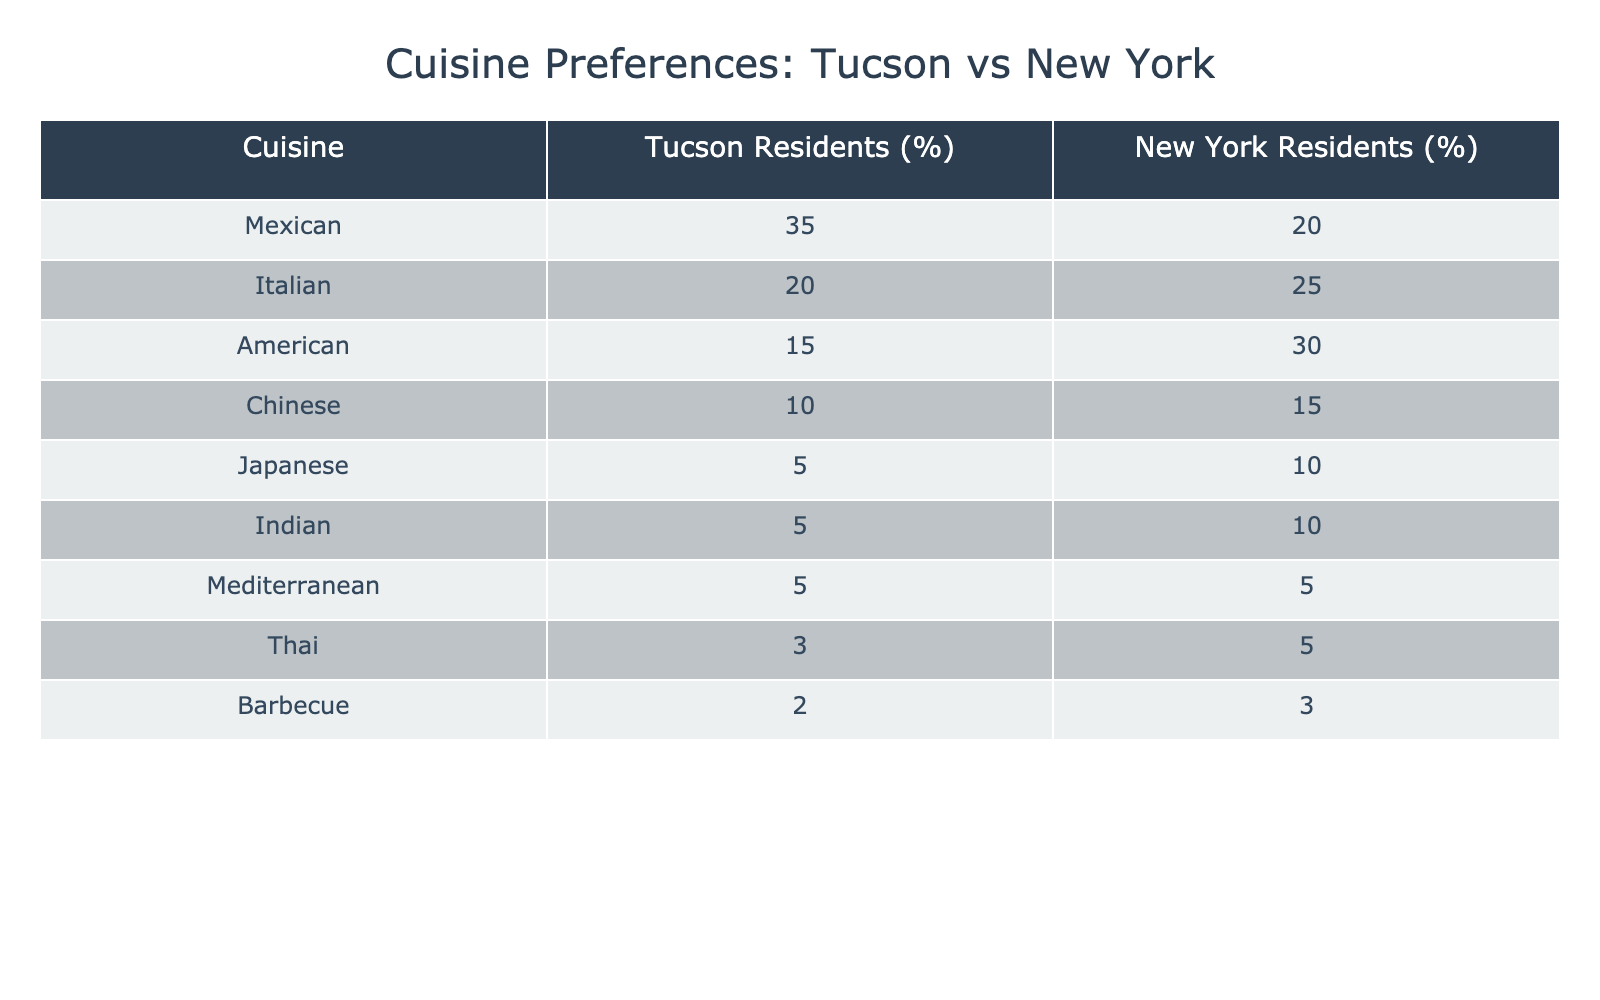What percentage of Tucson residents prefer Mexican cuisine? According to the table, Tucson residents prefer Mexican cuisine at a rate of 35%.
Answer: 35% What is the preferred cuisine for New York residents? The cuisine with the highest preference among New York residents is American, at 30%.
Answer: American How much more do Tucson residents prefer Italian cuisine compared to New York residents? Tucson residents prefer Italian cuisine at a rate of 20%, while New York residents prefer it at 25%. The difference is 20% - 25% = -5%, meaning Tucson residents actually prefer it 5% less.
Answer: 5% less What is the total percentage of Tucson residents who prefer Asian cuisines (Chinese, Japanese, Indian)? Summing up the percentages for Chinese (10%), Japanese (5%), and Indian (5%) gives us a total of 10 + 5 + 5 = 20% for Tucson residents preferring Asian cuisines.
Answer: 20% Is the percentage of New York residents who prefer Thai cuisine higher than that of Japanese cuisine? Thai cuisine is preferred by 5% of New York residents, and Japanese cuisine is also preferred by 10%. Since 5% is less than 10%, this statement is false.
Answer: No What is the average percentage of cuisine preference for Mediterranean cuisine in Tucson and New York? The percentage for Tucson is 5% and for New York is also 5%. The average is (5% + 5%) / 2 = 5%.
Answer: 5% What is the difference in the percentage of American cuisine preference between Tucson and New York residents? Tucson residents prefer American cuisine at 15% and New York residents at 30%. The difference is 15% - 30% = -15%, meaning New York residents prefer it 15% more.
Answer: 15% more Which cuisine has the lowest preference among Tucson residents compared to New York residents? The lowest preference for Tucson residents is Barbecue at 2%, while for New York residents it is also Barbecue at 3%. Therefore, Tucson residents have the lowest preference for this cuisine.
Answer: Barbecue 